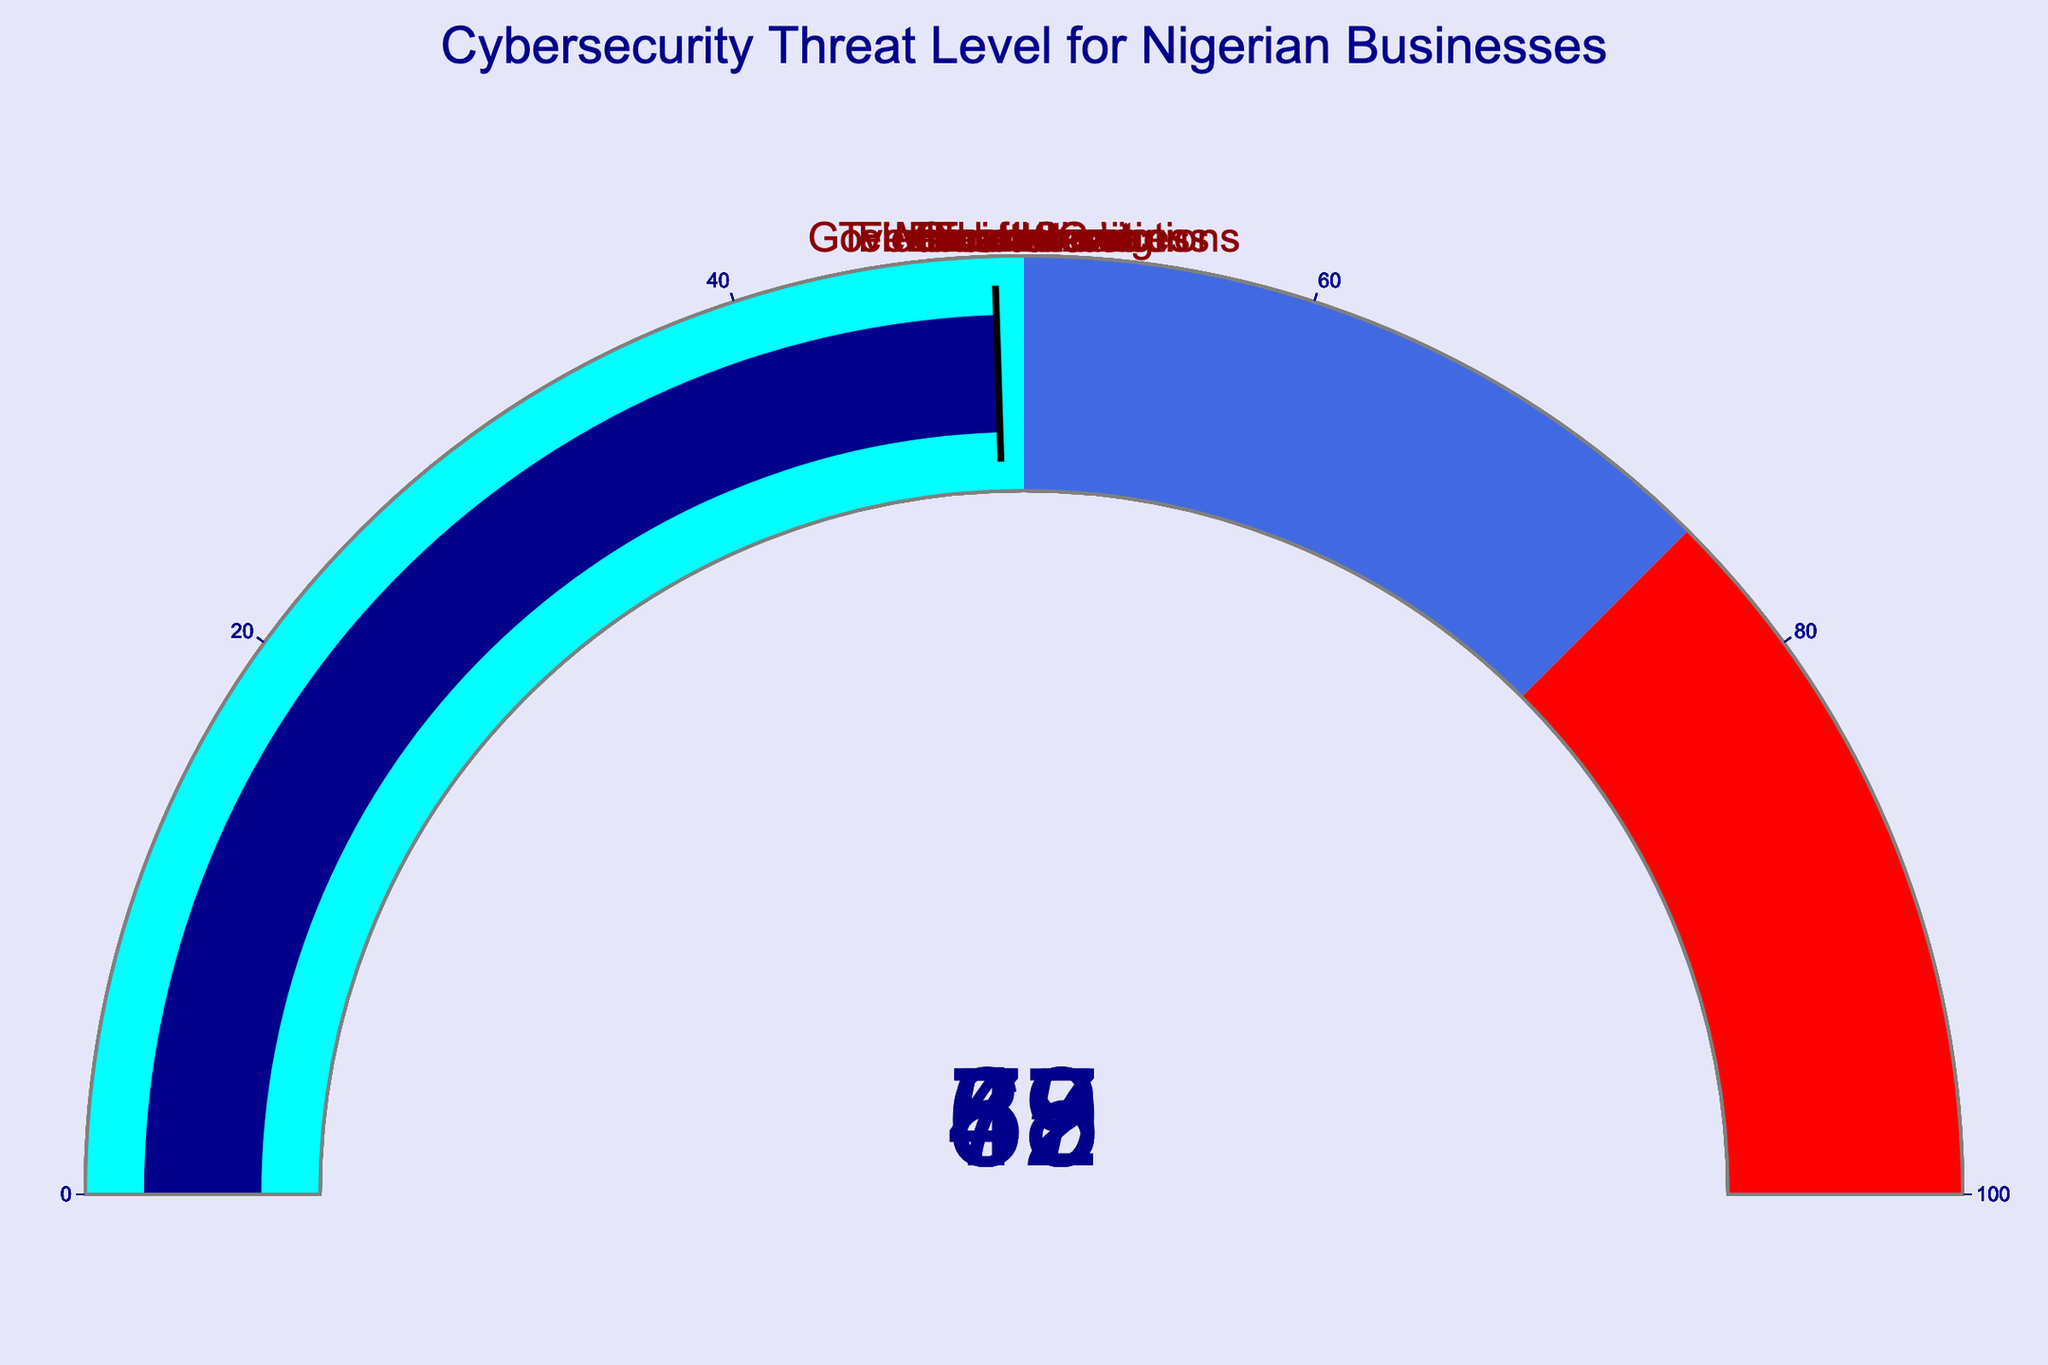Which sector has the highest cybersecurity threat level? The financial services sector has the highest threat level of 85, as indicated by the gauge chart.
Answer: Financial Services What is the spacing between the threat levels of Government Institutions and Telecommunications? The threat level for Government Institutions is 78, and for Telecommunications, it is 72. The difference between these values is 78 - 72.
Answer: 6 Which sector has a threat level of 57? The healthcare sector has a threat level of 57, according to the gauge chart indication.
Answer: Healthcare How many sectors have a threat level above 75? Based on the data representation on the gauge chart, Financial Services (85) and Government Institutions (78) have threat levels above 75.
Answer: 2 What is the average threat level of Oil and Gas, E-commerce, and Healthcare sectors? The threat levels for Oil and Gas, E-commerce, and Healthcare are 68, 62, and 57, respectively. The average is calculated as (68 + 62 + 57) / 3.
Answer: 62.33 What is the difference in the threat level between the highest and lowest sectors? The highest threat level is 85 (Financial Services), and the lowest is 49 (Education). The difference is 85 - 49.
Answer: 36 Which sector falls into the "royalblue" range of the gauge (50-75)? The Telecommunications, Oil and Gas, and E-commerce sectors fall into the range of 50 to 75, as represented by the "royalblue" color in the gauge chart.
Answer: Telecommunications, Oil and Gas, E-commerce Which sector has a threat level closest to 50? The Education sector has the threat level closest to 50 with an actual threat level of 49.
Answer: Education What is the combined threat level for the Manufacturing and Education sectors? The threat levels for the Manufacturing and Education sectors are 53 and 49, respectively. Their combined threat level is 53 + 49.
Answer: 102 What is the difference between the threat levels of E-commerce and Healthcare sectors? The threat levels for E-commerce and Healthcare sectors are 62 and 57, respectively. The difference between them is 62 - 57.
Answer: 5 